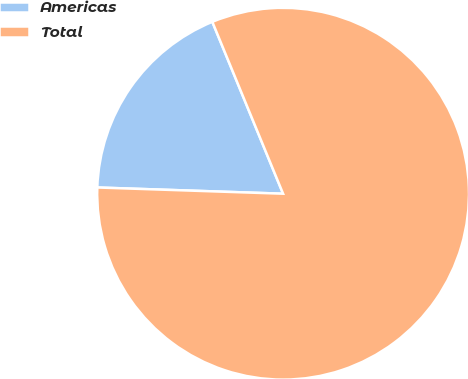<chart> <loc_0><loc_0><loc_500><loc_500><pie_chart><fcel>Americas<fcel>Total<nl><fcel>18.25%<fcel>81.75%<nl></chart> 